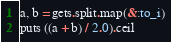<code> <loc_0><loc_0><loc_500><loc_500><_Ruby_>a, b = gets.split.map(&:to_i)
puts ((a + b) / 2.0).ceil</code> 